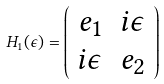<formula> <loc_0><loc_0><loc_500><loc_500>H _ { 1 } ( \epsilon ) = \left ( \begin{array} { c c } e _ { 1 } & i \epsilon \\ i \epsilon & e _ { 2 } \end{array} \right )</formula> 